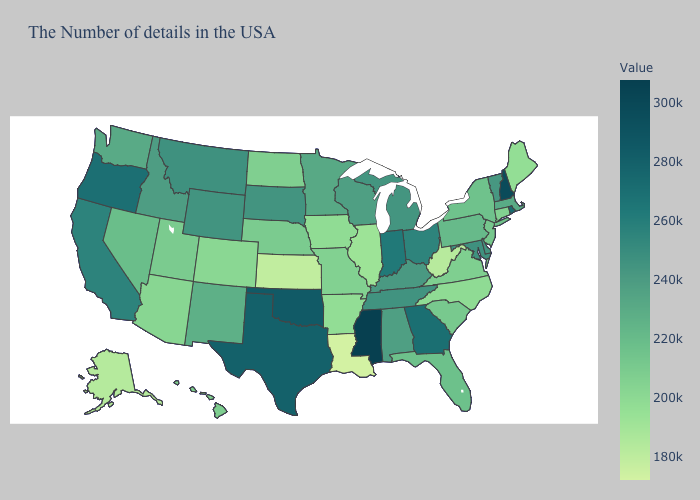Among the states that border Tennessee , which have the highest value?
Keep it brief. Mississippi. Does Mississippi have the highest value in the USA?
Write a very short answer. Yes. Does Louisiana have the lowest value in the USA?
Write a very short answer. Yes. Which states have the highest value in the USA?
Answer briefly. Mississippi. Among the states that border Washington , does Oregon have the highest value?
Keep it brief. Yes. Among the states that border Nevada , does Oregon have the lowest value?
Answer briefly. No. Among the states that border Nevada , which have the lowest value?
Give a very brief answer. Arizona. Among the states that border Nevada , which have the highest value?
Concise answer only. Oregon. 